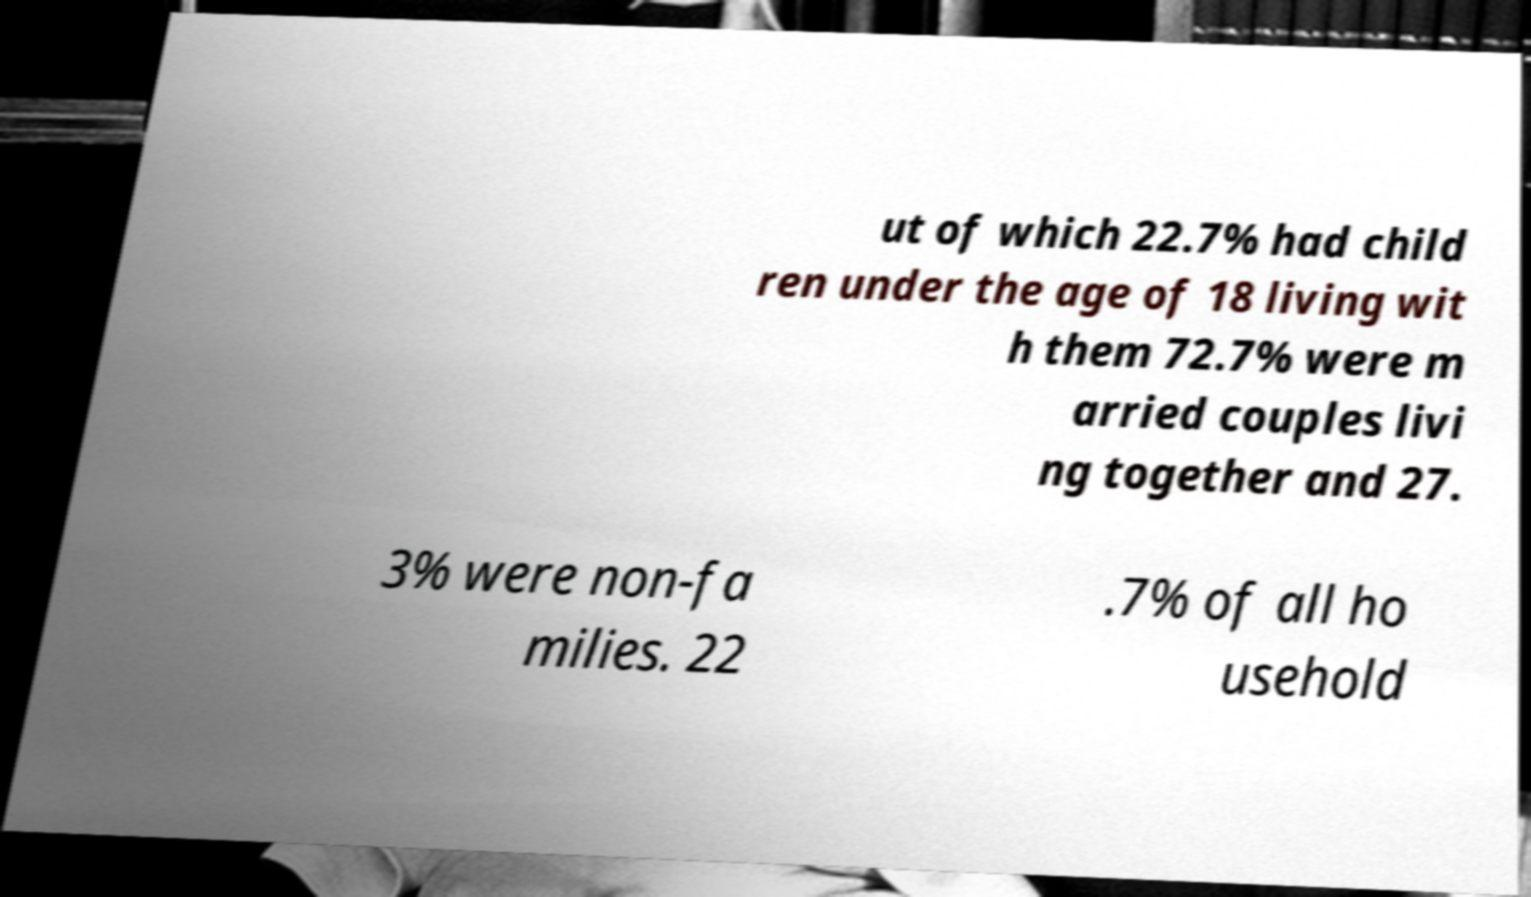Can you accurately transcribe the text from the provided image for me? ut of which 22.7% had child ren under the age of 18 living wit h them 72.7% were m arried couples livi ng together and 27. 3% were non-fa milies. 22 .7% of all ho usehold 